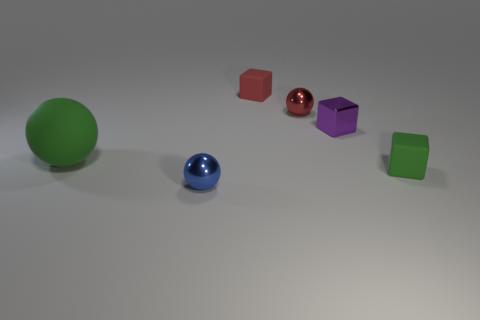What is the color of the small shiny ball to the left of the tiny matte block left of the small metallic ball that is to the right of the blue thing?
Ensure brevity in your answer.  Blue. Does the blue sphere have the same material as the tiny purple object?
Keep it short and to the point. Yes. There is a small shiny sphere that is to the left of the red object in front of the small red rubber block; is there a small rubber block that is behind it?
Ensure brevity in your answer.  Yes. Do the rubber sphere and the tiny metal block have the same color?
Offer a terse response. No. Are there fewer tiny shiny objects than blue things?
Give a very brief answer. No. Is the small blue thing in front of the large matte thing made of the same material as the block in front of the green matte ball?
Your response must be concise. No. Are there fewer blue metal objects that are right of the red metallic ball than large gray matte cylinders?
Your response must be concise. No. How many large green spheres are behind the small block that is in front of the large green matte ball?
Keep it short and to the point. 1. How big is the thing that is to the left of the red matte object and behind the blue object?
Offer a very short reply. Large. Are there any other things that are the same material as the small purple cube?
Keep it short and to the point. Yes. 